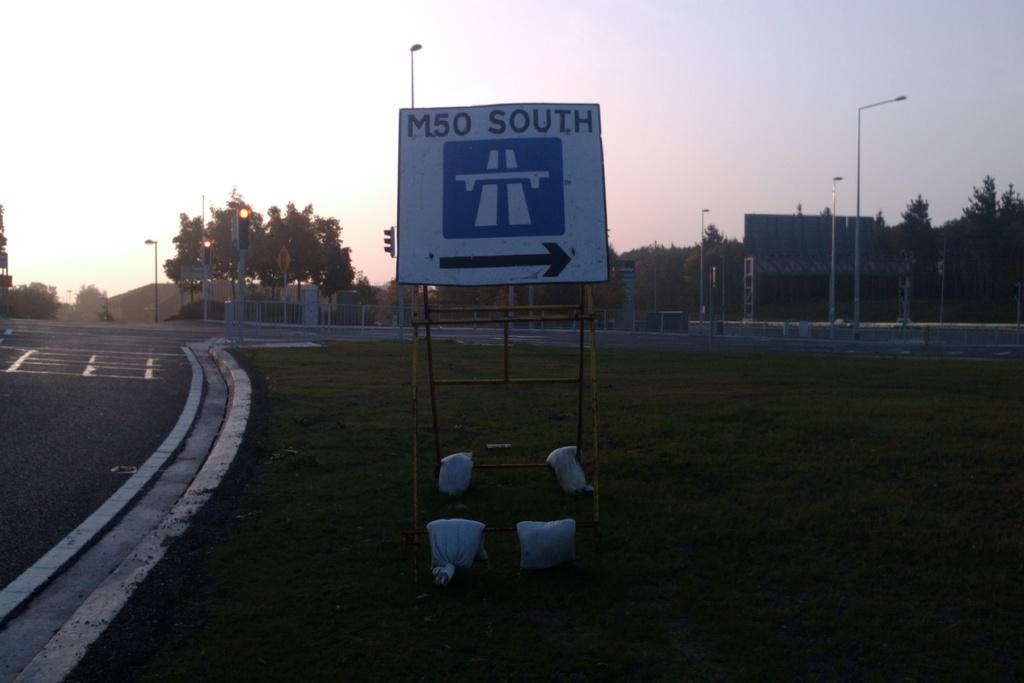What is the main feature of the image? There is a road in the image. What can be seen alongside the road? There are trees in the image. What helps regulate traffic in the image? Traffic signal lights are present in the image. What type of barrier is visible in the image? There is a fence in the image. What structures are supporting something in the image? Poles are visible in the image. What can help people navigate in the image? A direction board is present in the image. What is visible in the background of the image? The sky is visible in the background of the image. What type of secretary can be seen working at the sack in the image? There is no secretary or sack present in the image. How does the transport system operate in the image? The image does not show any transport system; it only features a road, trees, traffic signal lights, a fence, poles, a direction board, and the sky. 